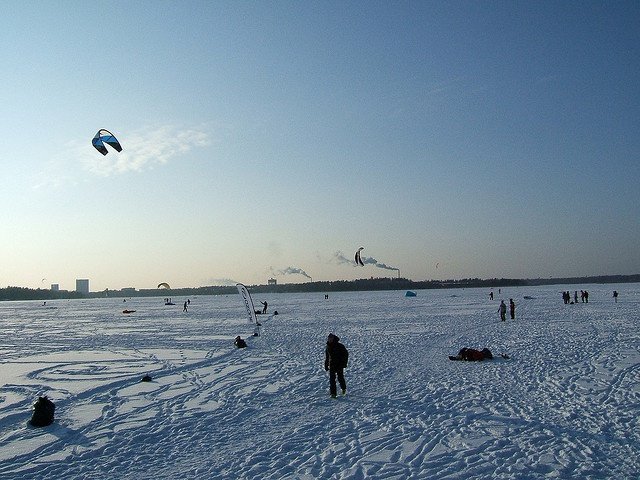Describe the objects in this image and their specific colors. I can see people in lightblue, black, gray, blue, and darkgray tones, backpack in lightblue, black, gray, and navy tones, kite in lightblue, black, teal, white, and navy tones, people in lightblue, black, and gray tones, and people in lightblue, black, gray, navy, and darkgray tones in this image. 